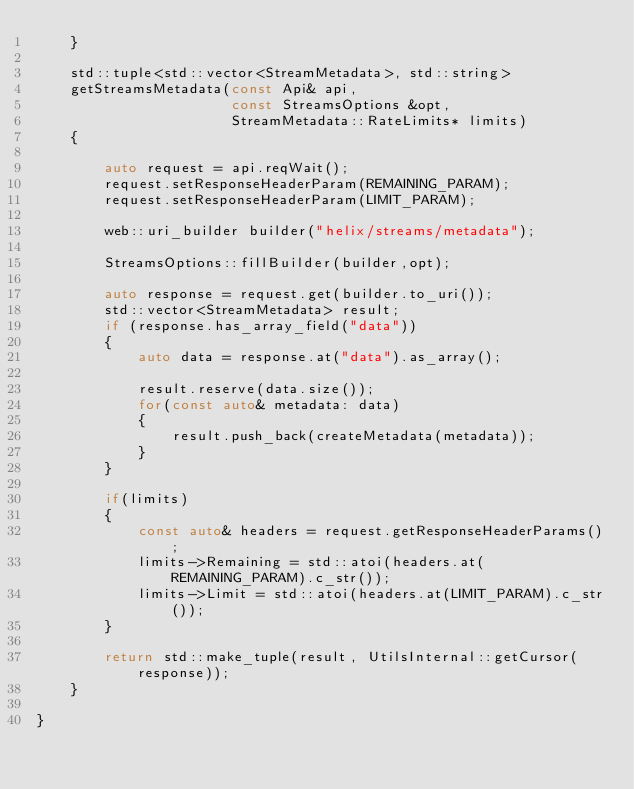Convert code to text. <code><loc_0><loc_0><loc_500><loc_500><_C++_>    }

    std::tuple<std::vector<StreamMetadata>, std::string>
    getStreamsMetadata(const Api& api,
                       const StreamsOptions &opt,
                       StreamMetadata::RateLimits* limits)
    {

        auto request = api.reqWait();
        request.setResponseHeaderParam(REMAINING_PARAM);
        request.setResponseHeaderParam(LIMIT_PARAM);

        web::uri_builder builder("helix/streams/metadata");

        StreamsOptions::fillBuilder(builder,opt);

        auto response = request.get(builder.to_uri());
        std::vector<StreamMetadata> result;
        if (response.has_array_field("data"))
        {
            auto data = response.at("data").as_array();

            result.reserve(data.size());
            for(const auto& metadata: data)
            {
                result.push_back(createMetadata(metadata));
            }
        }

        if(limits)
        {
            const auto& headers = request.getResponseHeaderParams();
            limits->Remaining = std::atoi(headers.at(REMAINING_PARAM).c_str());
            limits->Limit = std::atoi(headers.at(LIMIT_PARAM).c_str());
        }

        return std::make_tuple(result, UtilsInternal::getCursor(response));
    }

}
</code> 